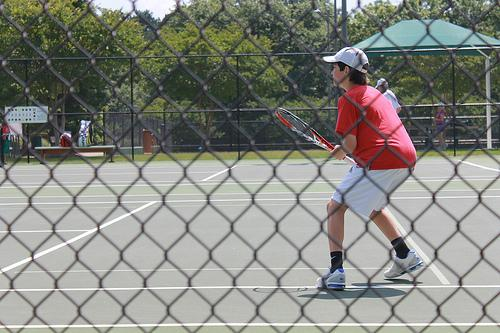Question: where was the photo taken?
Choices:
A. At the tennis court.
B. Basketball arena.
C. Ice rink.
D. Baseball court.
Answer with the letter. Answer: A Question: how many people on the court?
Choices:
A. 1.
B. 2.
C. 3.
D. 4.
Answer with the letter. Answer: A Question: what color is the man's shirt?
Choices:
A. Pink.
B. Purple.
C. Red.
D. Orange.
Answer with the letter. Answer: C Question: why is it so bright?
Choices:
A. Just woke up.
B. Lights on.
C. Too much paint.
D. Used a highlighter.
Answer with the letter. Answer: B 